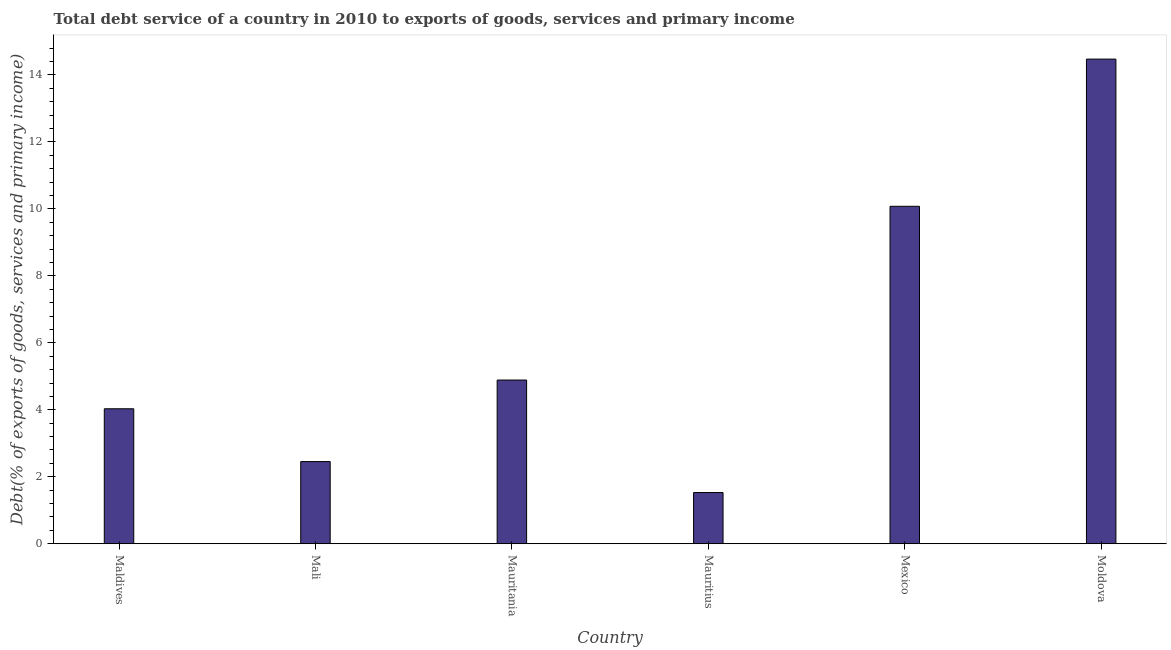Does the graph contain any zero values?
Offer a terse response. No. Does the graph contain grids?
Keep it short and to the point. No. What is the title of the graph?
Offer a very short reply. Total debt service of a country in 2010 to exports of goods, services and primary income. What is the label or title of the X-axis?
Offer a very short reply. Country. What is the label or title of the Y-axis?
Offer a terse response. Debt(% of exports of goods, services and primary income). What is the total debt service in Mexico?
Ensure brevity in your answer.  10.08. Across all countries, what is the maximum total debt service?
Ensure brevity in your answer.  14.47. Across all countries, what is the minimum total debt service?
Your answer should be very brief. 1.53. In which country was the total debt service maximum?
Give a very brief answer. Moldova. In which country was the total debt service minimum?
Your response must be concise. Mauritius. What is the sum of the total debt service?
Offer a terse response. 37.45. What is the difference between the total debt service in Mauritania and Mexico?
Provide a short and direct response. -5.19. What is the average total debt service per country?
Your answer should be very brief. 6.24. What is the median total debt service?
Your response must be concise. 4.46. What is the ratio of the total debt service in Maldives to that in Moldova?
Offer a very short reply. 0.28. Is the difference between the total debt service in Mali and Mauritania greater than the difference between any two countries?
Ensure brevity in your answer.  No. What is the difference between the highest and the second highest total debt service?
Your response must be concise. 4.4. What is the difference between the highest and the lowest total debt service?
Your answer should be very brief. 12.94. How many countries are there in the graph?
Give a very brief answer. 6. What is the difference between two consecutive major ticks on the Y-axis?
Ensure brevity in your answer.  2. What is the Debt(% of exports of goods, services and primary income) of Maldives?
Ensure brevity in your answer.  4.03. What is the Debt(% of exports of goods, services and primary income) of Mali?
Your answer should be compact. 2.45. What is the Debt(% of exports of goods, services and primary income) of Mauritania?
Make the answer very short. 4.89. What is the Debt(% of exports of goods, services and primary income) in Mauritius?
Offer a terse response. 1.53. What is the Debt(% of exports of goods, services and primary income) of Mexico?
Offer a very short reply. 10.08. What is the Debt(% of exports of goods, services and primary income) of Moldova?
Your response must be concise. 14.47. What is the difference between the Debt(% of exports of goods, services and primary income) in Maldives and Mali?
Offer a very short reply. 1.58. What is the difference between the Debt(% of exports of goods, services and primary income) in Maldives and Mauritania?
Keep it short and to the point. -0.86. What is the difference between the Debt(% of exports of goods, services and primary income) in Maldives and Mauritius?
Ensure brevity in your answer.  2.5. What is the difference between the Debt(% of exports of goods, services and primary income) in Maldives and Mexico?
Your answer should be compact. -6.05. What is the difference between the Debt(% of exports of goods, services and primary income) in Maldives and Moldova?
Your answer should be compact. -10.44. What is the difference between the Debt(% of exports of goods, services and primary income) in Mali and Mauritania?
Offer a very short reply. -2.43. What is the difference between the Debt(% of exports of goods, services and primary income) in Mali and Mauritius?
Keep it short and to the point. 0.93. What is the difference between the Debt(% of exports of goods, services and primary income) in Mali and Mexico?
Your answer should be compact. -7.62. What is the difference between the Debt(% of exports of goods, services and primary income) in Mali and Moldova?
Give a very brief answer. -12.02. What is the difference between the Debt(% of exports of goods, services and primary income) in Mauritania and Mauritius?
Provide a short and direct response. 3.36. What is the difference between the Debt(% of exports of goods, services and primary income) in Mauritania and Mexico?
Ensure brevity in your answer.  -5.19. What is the difference between the Debt(% of exports of goods, services and primary income) in Mauritania and Moldova?
Offer a very short reply. -9.58. What is the difference between the Debt(% of exports of goods, services and primary income) in Mauritius and Mexico?
Offer a very short reply. -8.55. What is the difference between the Debt(% of exports of goods, services and primary income) in Mauritius and Moldova?
Make the answer very short. -12.94. What is the difference between the Debt(% of exports of goods, services and primary income) in Mexico and Moldova?
Offer a very short reply. -4.4. What is the ratio of the Debt(% of exports of goods, services and primary income) in Maldives to that in Mali?
Offer a very short reply. 1.64. What is the ratio of the Debt(% of exports of goods, services and primary income) in Maldives to that in Mauritania?
Offer a terse response. 0.82. What is the ratio of the Debt(% of exports of goods, services and primary income) in Maldives to that in Mauritius?
Offer a terse response. 2.64. What is the ratio of the Debt(% of exports of goods, services and primary income) in Maldives to that in Moldova?
Provide a short and direct response. 0.28. What is the ratio of the Debt(% of exports of goods, services and primary income) in Mali to that in Mauritania?
Your answer should be compact. 0.5. What is the ratio of the Debt(% of exports of goods, services and primary income) in Mali to that in Mauritius?
Your answer should be compact. 1.6. What is the ratio of the Debt(% of exports of goods, services and primary income) in Mali to that in Mexico?
Provide a short and direct response. 0.24. What is the ratio of the Debt(% of exports of goods, services and primary income) in Mali to that in Moldova?
Provide a short and direct response. 0.17. What is the ratio of the Debt(% of exports of goods, services and primary income) in Mauritania to that in Mauritius?
Your response must be concise. 3.2. What is the ratio of the Debt(% of exports of goods, services and primary income) in Mauritania to that in Mexico?
Provide a short and direct response. 0.48. What is the ratio of the Debt(% of exports of goods, services and primary income) in Mauritania to that in Moldova?
Your response must be concise. 0.34. What is the ratio of the Debt(% of exports of goods, services and primary income) in Mauritius to that in Mexico?
Offer a terse response. 0.15. What is the ratio of the Debt(% of exports of goods, services and primary income) in Mauritius to that in Moldova?
Offer a terse response. 0.11. What is the ratio of the Debt(% of exports of goods, services and primary income) in Mexico to that in Moldova?
Your answer should be very brief. 0.7. 